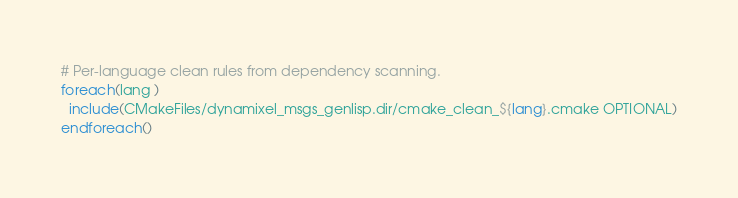<code> <loc_0><loc_0><loc_500><loc_500><_CMake_>
# Per-language clean rules from dependency scanning.
foreach(lang )
  include(CMakeFiles/dynamixel_msgs_genlisp.dir/cmake_clean_${lang}.cmake OPTIONAL)
endforeach()
</code> 